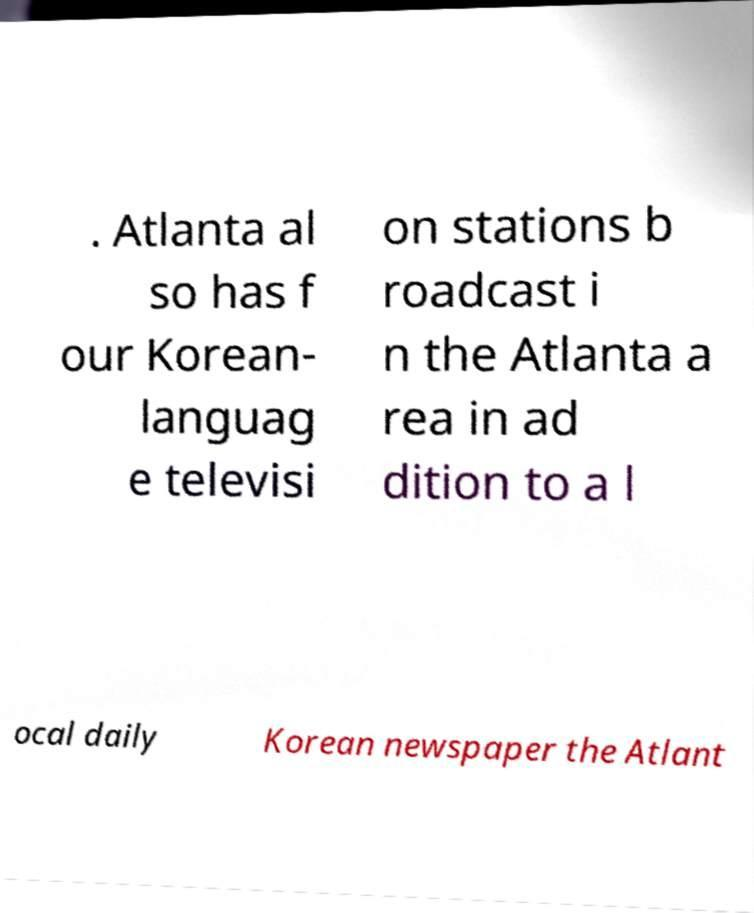I need the written content from this picture converted into text. Can you do that? . Atlanta al so has f our Korean- languag e televisi on stations b roadcast i n the Atlanta a rea in ad dition to a l ocal daily Korean newspaper the Atlant 